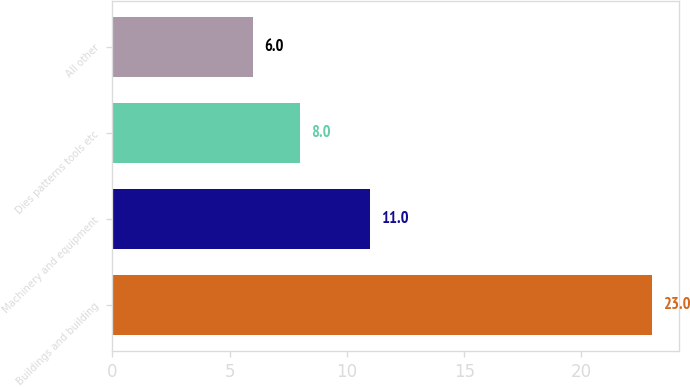Convert chart. <chart><loc_0><loc_0><loc_500><loc_500><bar_chart><fcel>Buildings and building<fcel>Machinery and equipment<fcel>Dies patterns tools etc<fcel>All other<nl><fcel>23<fcel>11<fcel>8<fcel>6<nl></chart> 